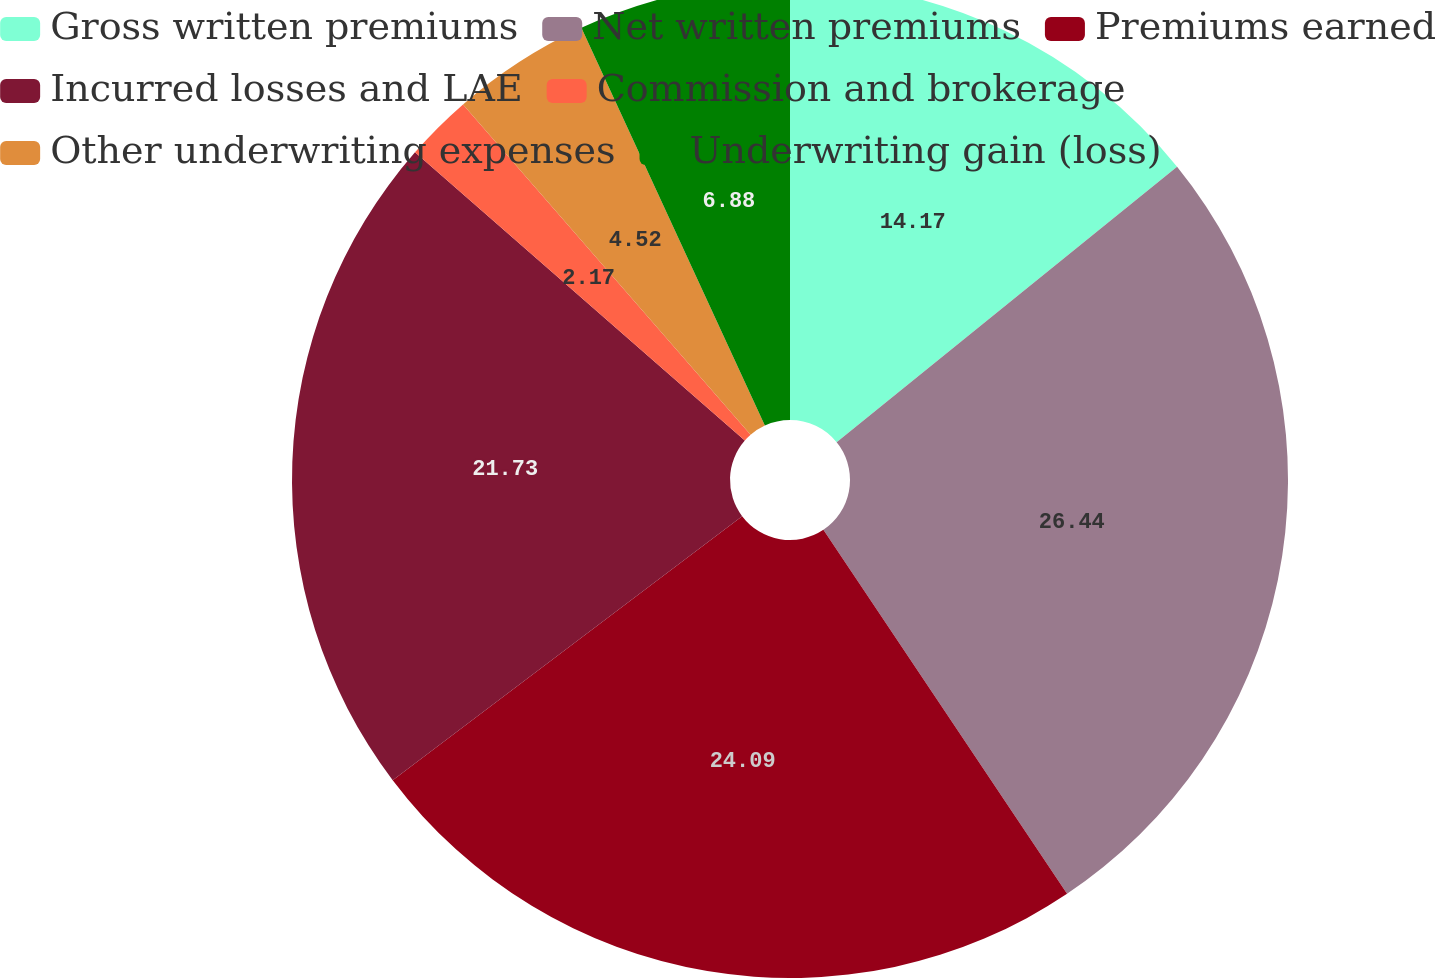Convert chart. <chart><loc_0><loc_0><loc_500><loc_500><pie_chart><fcel>Gross written premiums<fcel>Net written premiums<fcel>Premiums earned<fcel>Incurred losses and LAE<fcel>Commission and brokerage<fcel>Other underwriting expenses<fcel>Underwriting gain (loss)<nl><fcel>14.17%<fcel>26.44%<fcel>24.09%<fcel>21.73%<fcel>2.17%<fcel>4.52%<fcel>6.88%<nl></chart> 